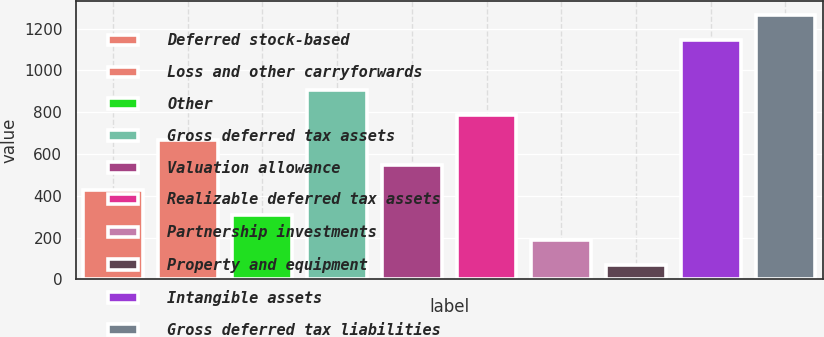Convert chart. <chart><loc_0><loc_0><loc_500><loc_500><bar_chart><fcel>Deferred stock-based<fcel>Loss and other carryforwards<fcel>Other<fcel>Gross deferred tax assets<fcel>Valuation allowance<fcel>Realizable deferred tax assets<fcel>Partnership investments<fcel>Property and equipment<fcel>Intangible assets<fcel>Gross deferred tax liabilities<nl><fcel>428.65<fcel>668.15<fcel>308.9<fcel>907.65<fcel>548.4<fcel>787.9<fcel>189.15<fcel>69.4<fcel>1147.15<fcel>1266.9<nl></chart> 